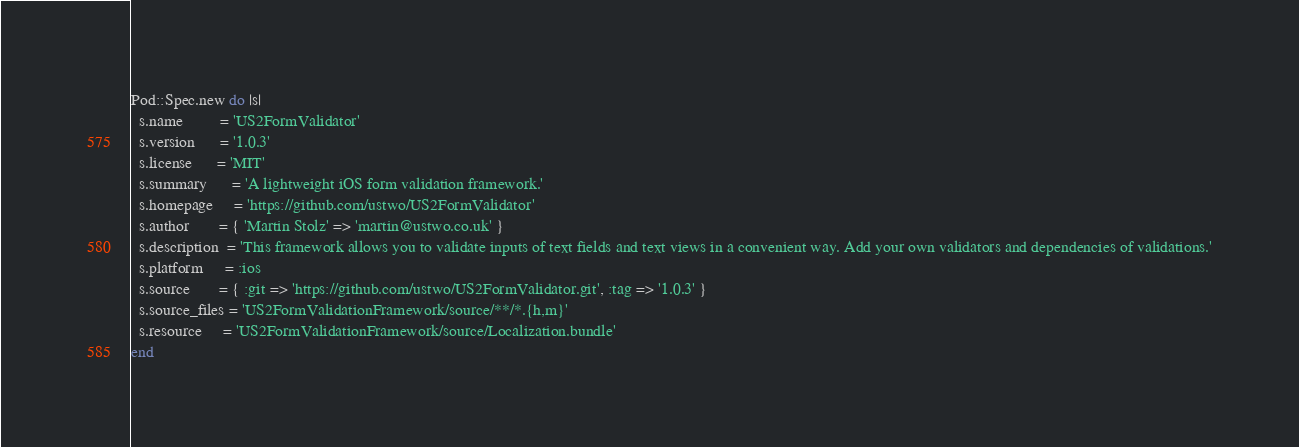Convert code to text. <code><loc_0><loc_0><loc_500><loc_500><_Ruby_>Pod::Spec.new do |s|
  s.name         = 'US2FormValidator'
  s.version      = '1.0.3'
  s.license      = 'MIT'
  s.summary      = 'A lightweight iOS form validation framework.'
  s.homepage     = 'https://github.com/ustwo/US2FormValidator'
  s.author       = { 'Martin Stolz' => 'martin@ustwo.co.uk' }
  s.description  = 'This framework allows you to validate inputs of text fields and text views in a convenient way. Add your own validators and dependencies of validations.'
  s.platform     = :ios
  s.source       = { :git => 'https://github.com/ustwo/US2FormValidator.git', :tag => '1.0.3' }
  s.source_files = 'US2FormValidationFramework/source/**/*.{h,m}'
  s.resource     = 'US2FormValidationFramework/source/Localization.bundle'
end
</code> 